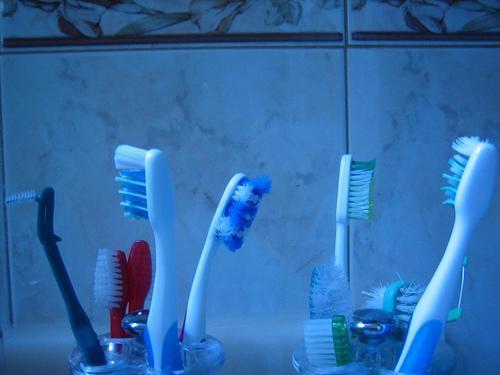How many cups are visible?
Give a very brief answer. 2. How many toothbrushes are in the picture?
Give a very brief answer. 8. 